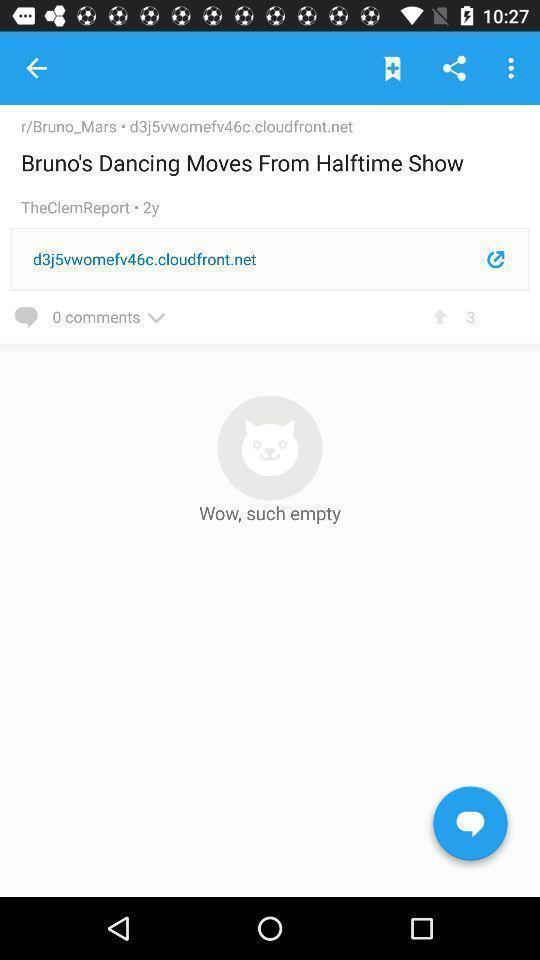Provide a description of this screenshot. Image shows profile in a social application. 